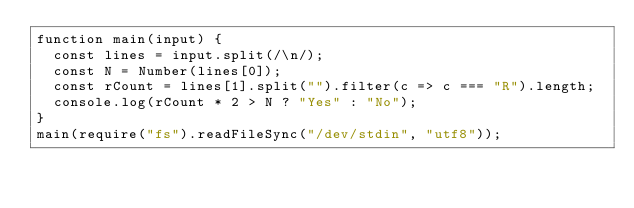Convert code to text. <code><loc_0><loc_0><loc_500><loc_500><_JavaScript_>function main(input) {
  const lines = input.split(/\n/);
  const N = Number(lines[0]);
  const rCount = lines[1].split("").filter(c => c === "R").length;
  console.log(rCount * 2 > N ? "Yes" : "No");
}
main(require("fs").readFileSync("/dev/stdin", "utf8"));
</code> 